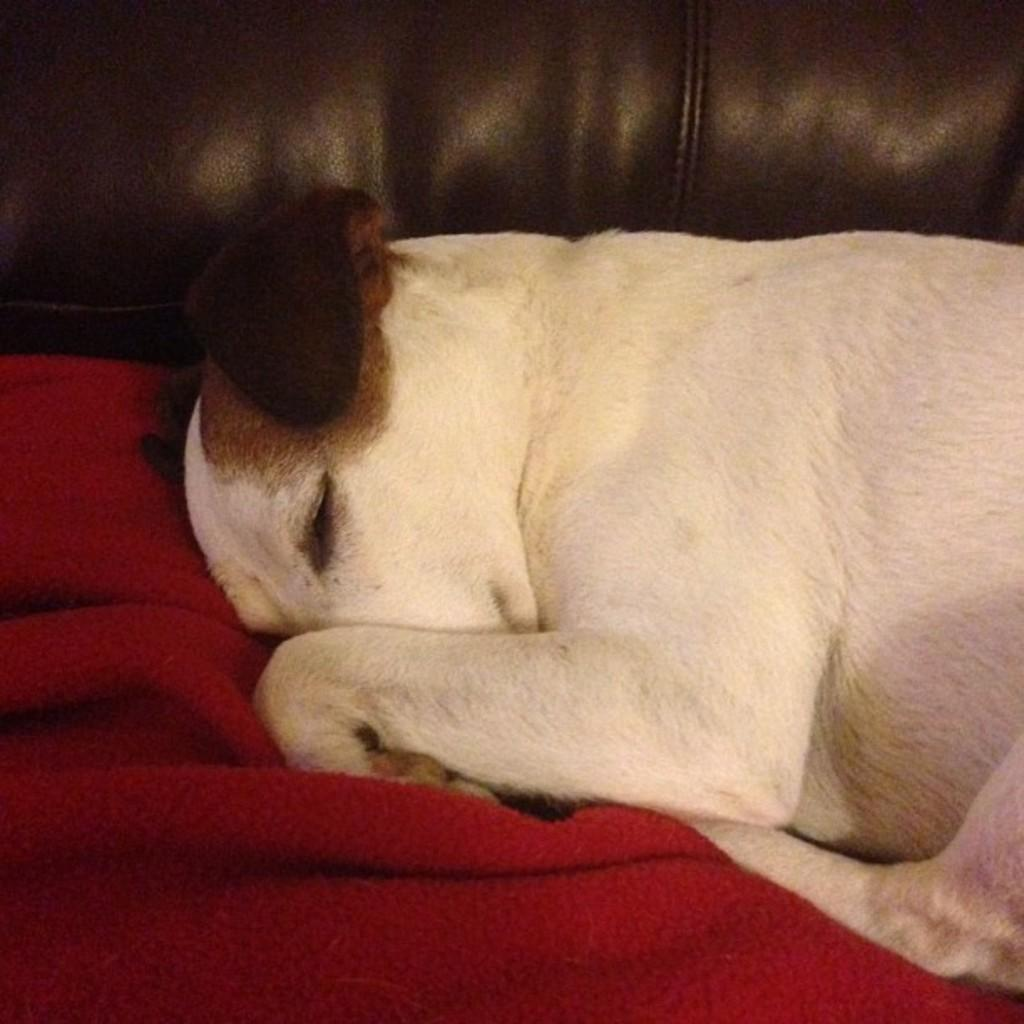What type of animal can be seen in the image? There is a dog in the image. What is the dog doing in the image? The dog is sleeping on the sofa. Can you describe any other objects in the image? There is a red towel in the image. What idea does the dog have about the plane in the image? There is no plane present in the image, so the dog cannot have any idea about it. 